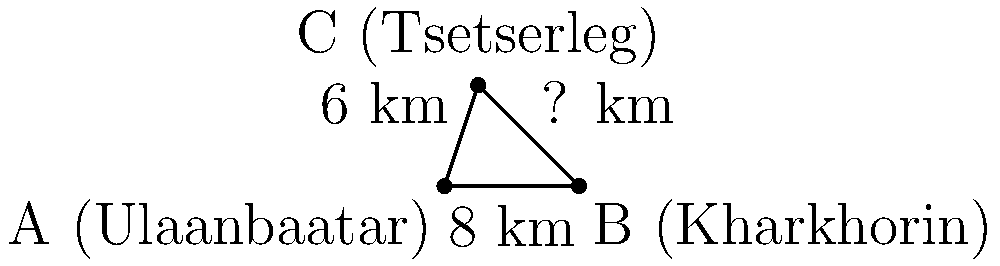On a map of central Mongolia, three landmarks form a right-angled triangle: Ulaanbaatar (A), Kharkhorin (B), and Tsetserleg (C). The distance from Ulaanbaatar to Kharkhorin is 8 km, and from Ulaanbaatar to Tsetserleg is 6 km. Using the Pythagorean theorem, calculate the distance between Kharkhorin and Tsetserleg. Let's approach this step-by-step:

1) We have a right-angled triangle where:
   - The base (AB) is 8 km
   - The height (AC) is 6 km
   - We need to find the hypotenuse (BC)

2) The Pythagorean theorem states that in a right-angled triangle:
   $a^2 + b^2 = c^2$
   where c is the length of the hypotenuse and a and b are the lengths of the other two sides.

3) Let's substitute our known values:
   $8^2 + 6^2 = c^2$

4) Simplify:
   $64 + 36 = c^2$
   $100 = c^2$

5) To find c, we need to take the square root of both sides:
   $\sqrt{100} = c$

6) Simplify:
   $10 = c$

Therefore, the distance between Kharkhorin and Tsetserleg is 10 km.
Answer: 10 km 